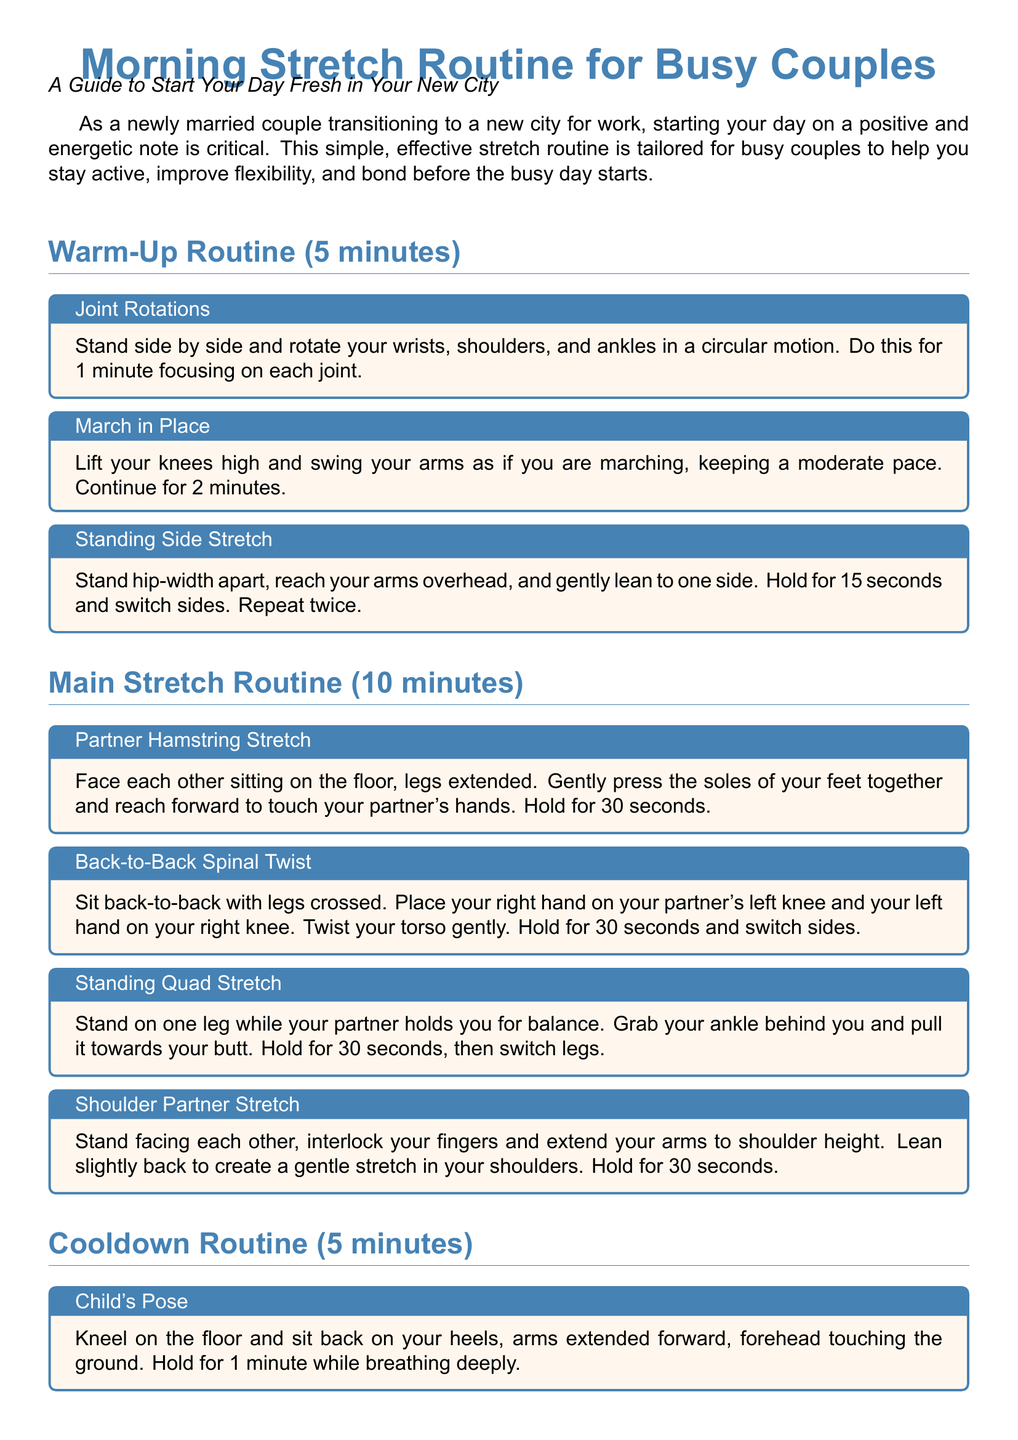What is the title of the workout routine? The title of the workout routine is stated at the beginning of the document.
Answer: Morning Stretch Routine for Busy Couples How long is the warm-up routine? The duration of the warm-up routine is indicated in the section title.
Answer: 5 minutes What is the partner stretch that involves hamstrings? The specific partner stretch mentioned in the main routine targets the hamstrings.
Answer: Partner Hamstring Stretch How many exercises are in the cooldown routine? The number of exercises in the cooldown routine can be counted from the listed blocks.
Answer: 3 What should couples focus on during the warm-up routine? This question pertains to the emphasis placed on joint movements in the warm-up.
Answer: Joint Rotations Which stretch involves leaning back while holding hands? This requires recalling the stretch that involves partners intertwining fingers and leaning.
Answer: Shoulder Partner Stretch How long should couples hold the Child's Pose stretch? The duration to hold this specific stretch is noted in the cooldown section.
Answer: 1 minute What is the purpose of the morning stretch routine? The overall intent of the routine is described in the introductory paragraph.
Answer: To start your day fresh 